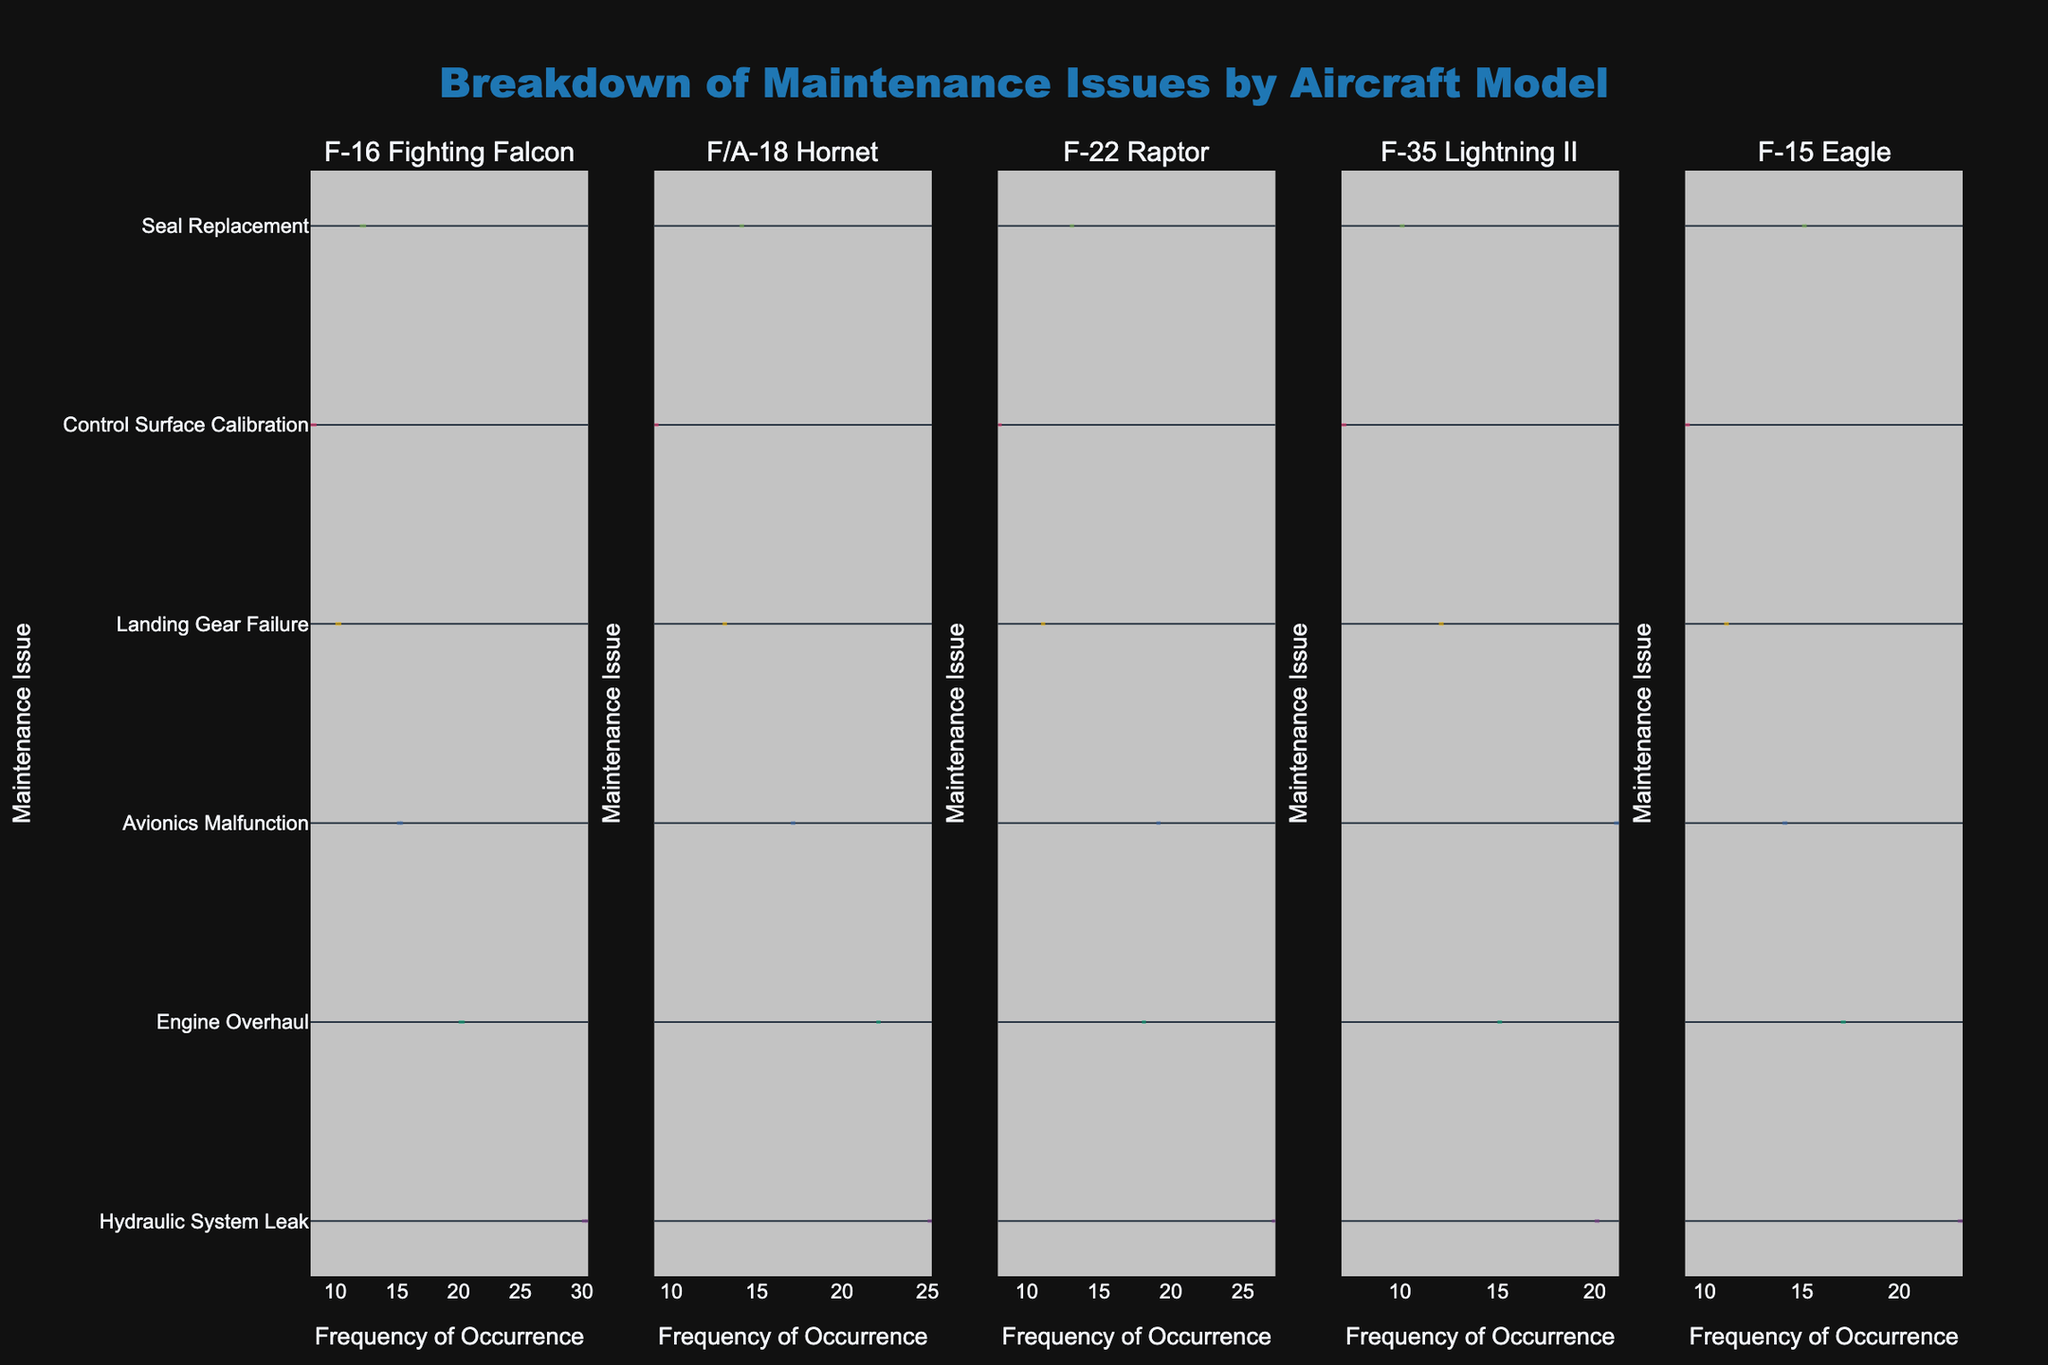what is the title of the chart? The title sits at the top of the chart, usually in bold and larger font than the rest of the text. From the given code, it is 'Breakdown of Maintenance Issues by Aircraft Model'.
Answer: Breakdown of Maintenance Issues by Aircraft Model which aircraft model has the highest frequency for Hydraulic System Leak? Looking at each subplot, examine the distribution for each aircraft model. The F-16 Fighting Falcon has the highest peak.
Answer: F-16 Fighting Falcon how do the frequencies of Avionics Malfunction compare between the F-22 Raptor and F-35 Lightning II? Look at the distributions for Avionics Malfunctions in both subplots for F-22 Raptor and F-35 Lightning II. F-35 Lightning II has a slightly higher frequency than F-22 Raptor.
Answer: F-35 Lightning II has a higher frequency which maintenance issue is most common across all aircraft models? Evaluate the meanlines for each maintenance issue across all subplots. Hydraulic System Leak appears to have the highest meanlines in most subplots.
Answer: Hydraulic System Leak which aircraft model has the lowest frequency for Control Surface Calibration? Examine the subplots for each aircraft model, specifically looking at the y-axis for Control Surface Calibration. F-35 Lightning II has the lowest frequency.
Answer: F-35 Lightning II what's the total count of maintenance issues for Seal Replacement in all models? Sum the frequencies for Seal Replacement across all subplots: 12 (F-16) + 14 (F/A-18) + 13 (F-22) + 10 (F-35) + 15 (F-15). The total is 64.
Answer: 64 what's the average occurrence frequency for Engine Overhaul in the F-16 Fighting Falcon? For the F-16 segment, there's a frequency of 20 for Engine Overhaul. The average is calculated from this frequency since there is only one occurrence.
Answer: 20 compare the frequency of Landing Gear Failure between F/A-18 Hornet and F-15 Eagle. Which one is higher? In the F/A-18 subplot, the frequency is 13 and in the F-15 subplot, the frequency is 11. F/A-18 Hornet has a higher frequency.
Answer: F/A-18 Hornet what's the median frequency of Avionics Malfunction across all aircraft models? List the frequencies of Avionics Malfunction: 15 (F-16) + 17 (F/A-18) + 19 (F-22) + 21 (F-35) + 14 (F-15); ordering them gives 14, 15, 17, 19, 21. The median is the middle value, 17.
Answer: 17 